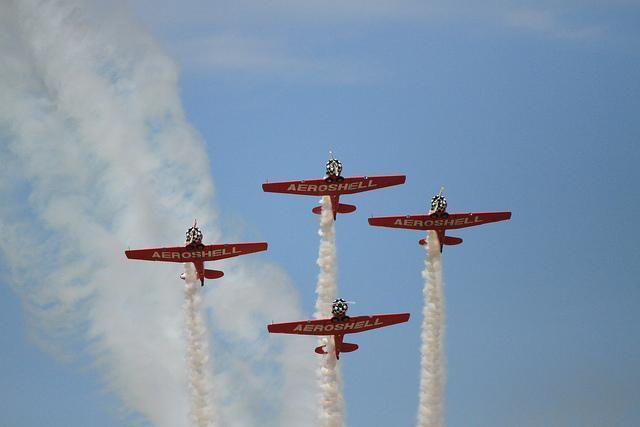How many airplanes are there?
Give a very brief answer. 4. 